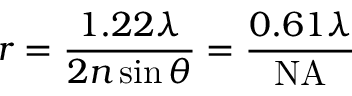<formula> <loc_0><loc_0><loc_500><loc_500>r = { \frac { 1 . 2 2 \lambda } { 2 n \sin { \theta } } } = { \frac { 0 . 6 1 \lambda } { N A } }</formula> 